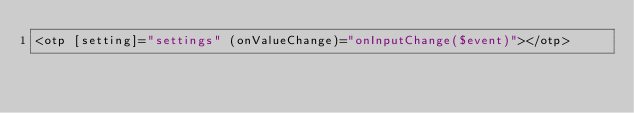Convert code to text. <code><loc_0><loc_0><loc_500><loc_500><_HTML_><otp [setting]="settings" (onValueChange)="onInputChange($event)"></otp></code> 